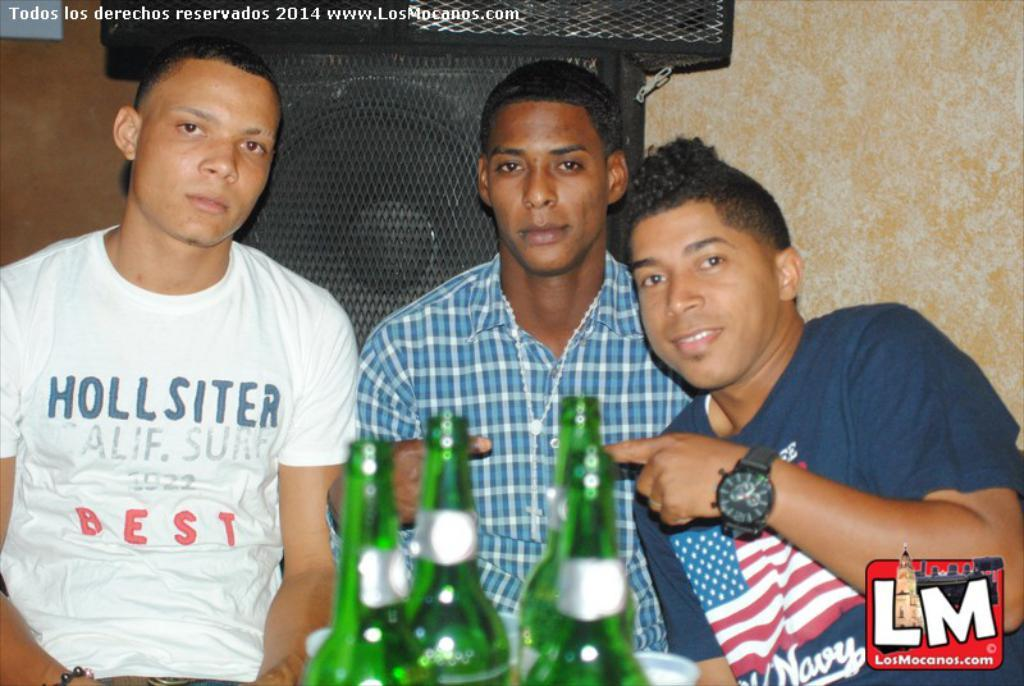How many people are in the image? There are three persons in the image. What is the person wearing in the blue t-shirt doing? We cannot determine their actions from the provided facts. What accessory is the person in the blue t-shirt wearing? The person in the blue t-shirt is wearing a watch. What objects can be seen in the image besides the people? There are bottles visible in the image. What can be seen in the background of the image? There is a speaker in the background of the image. What type of credit card is the person in the blue t-shirt using in the image? There is no credit card visible in the image. What is the person in the blue t-shirt eating for breakfast in the image? There is no information about breakfast or any food in the image. 